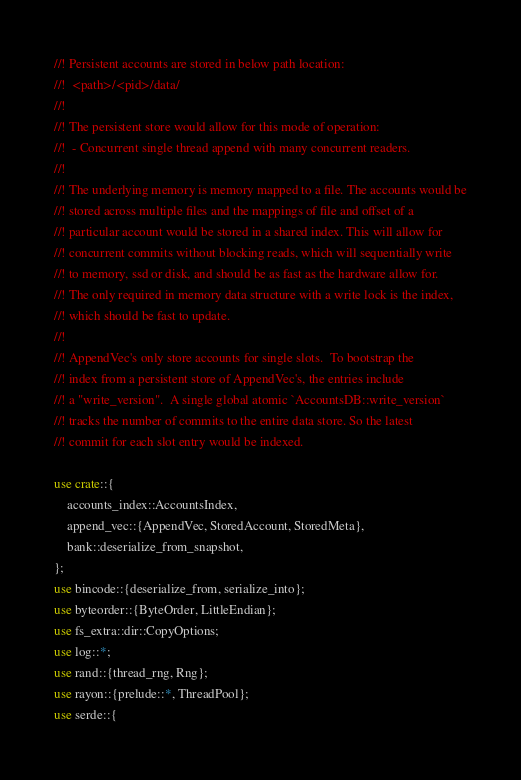<code> <loc_0><loc_0><loc_500><loc_500><_Rust_>//! Persistent accounts are stored in below path location:
//!  <path>/<pid>/data/
//!
//! The persistent store would allow for this mode of operation:
//!  - Concurrent single thread append with many concurrent readers.
//!
//! The underlying memory is memory mapped to a file. The accounts would be
//! stored across multiple files and the mappings of file and offset of a
//! particular account would be stored in a shared index. This will allow for
//! concurrent commits without blocking reads, which will sequentially write
//! to memory, ssd or disk, and should be as fast as the hardware allow for.
//! The only required in memory data structure with a write lock is the index,
//! which should be fast to update.
//!
//! AppendVec's only store accounts for single slots.  To bootstrap the
//! index from a persistent store of AppendVec's, the entries include
//! a "write_version".  A single global atomic `AccountsDB::write_version`
//! tracks the number of commits to the entire data store. So the latest
//! commit for each slot entry would be indexed.

use crate::{
    accounts_index::AccountsIndex,
    append_vec::{AppendVec, StoredAccount, StoredMeta},
    bank::deserialize_from_snapshot,
};
use bincode::{deserialize_from, serialize_into};
use byteorder::{ByteOrder, LittleEndian};
use fs_extra::dir::CopyOptions;
use log::*;
use rand::{thread_rng, Rng};
use rayon::{prelude::*, ThreadPool};
use serde::{</code> 